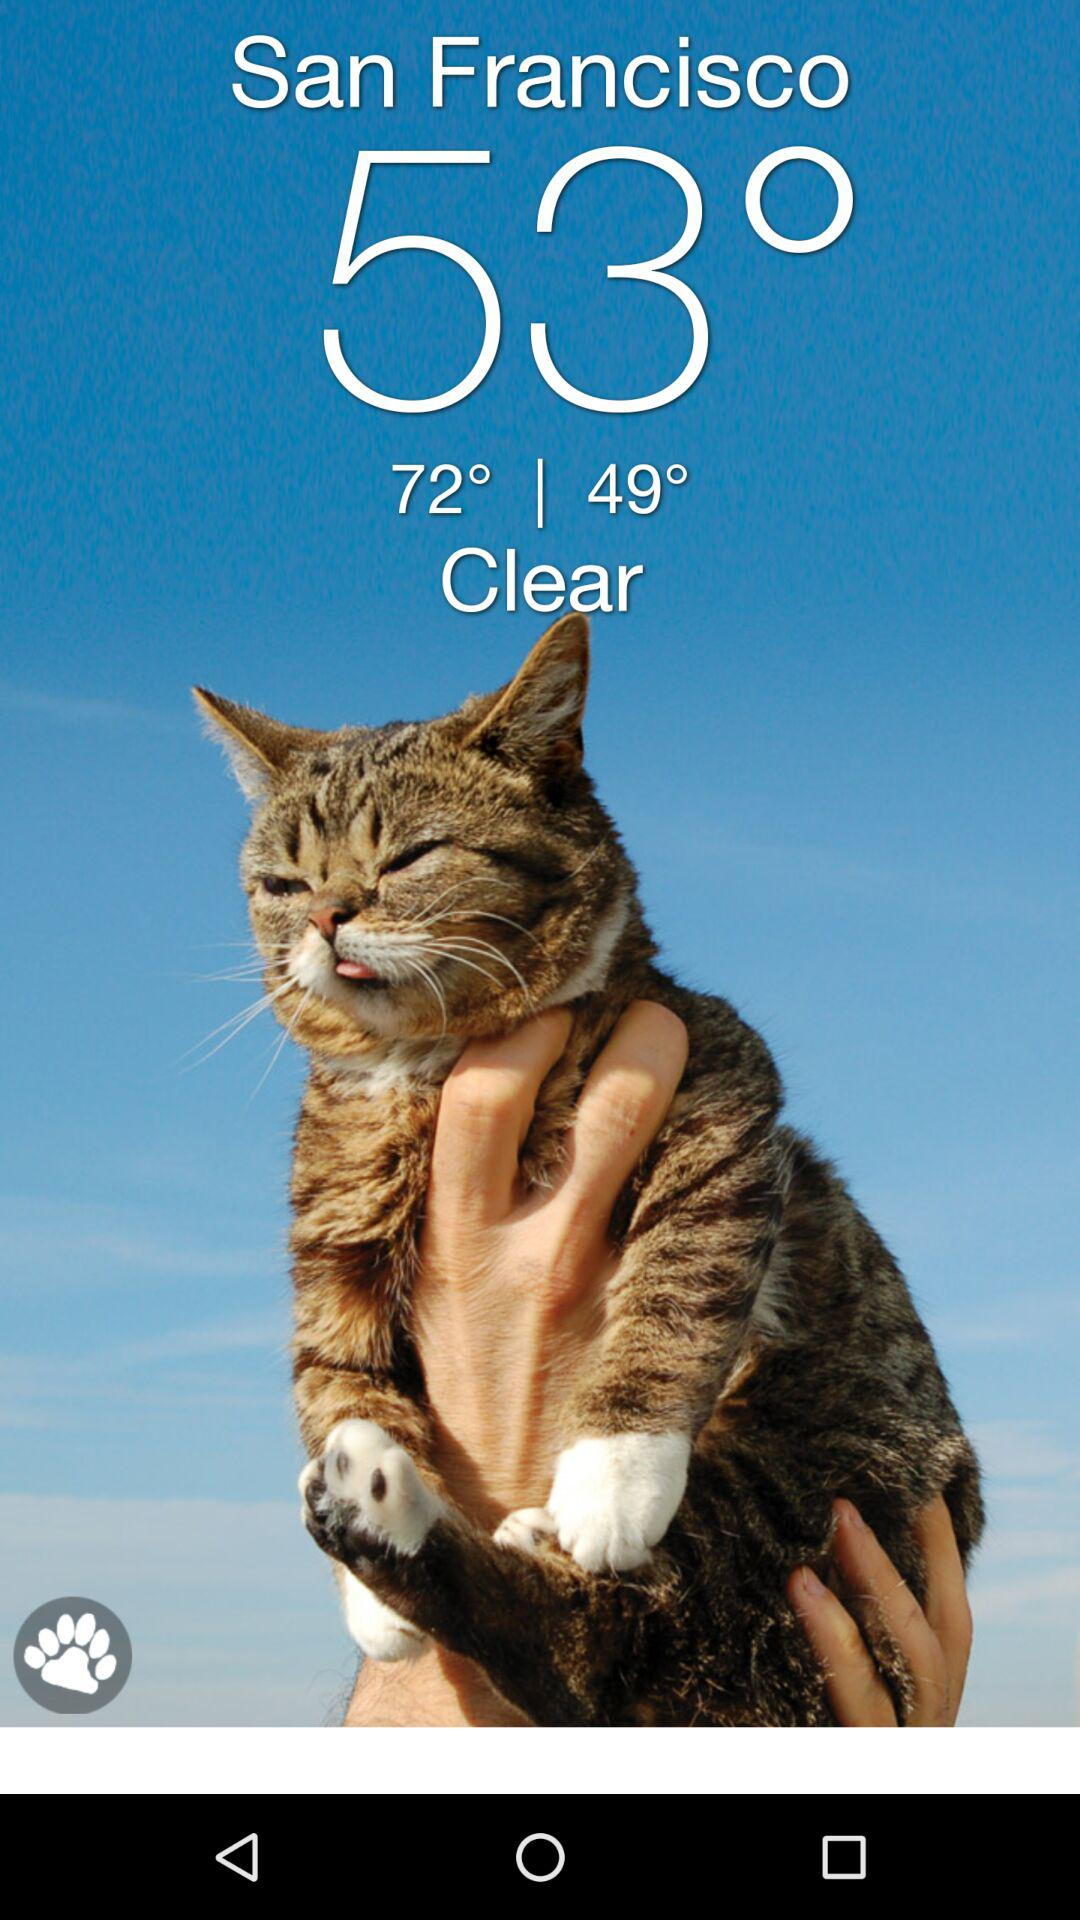How many degrees is the temperature difference between the highest and lowest temperatures?
Answer the question using a single word or phrase. 23 